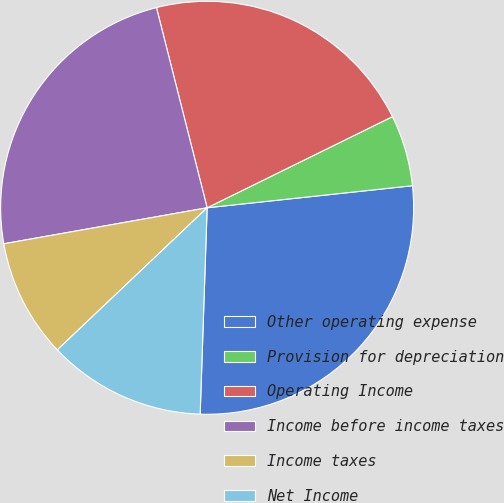Convert chart. <chart><loc_0><loc_0><loc_500><loc_500><pie_chart><fcel>Other operating expense<fcel>Provision for depreciation<fcel>Operating Income<fcel>Income before income taxes<fcel>Income taxes<fcel>Net Income<nl><fcel>27.24%<fcel>5.57%<fcel>21.67%<fcel>23.84%<fcel>9.29%<fcel>12.38%<nl></chart> 